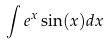Convert formula to latex. <formula><loc_0><loc_0><loc_500><loc_500>\int e ^ { x } \sin ( x ) d x</formula> 